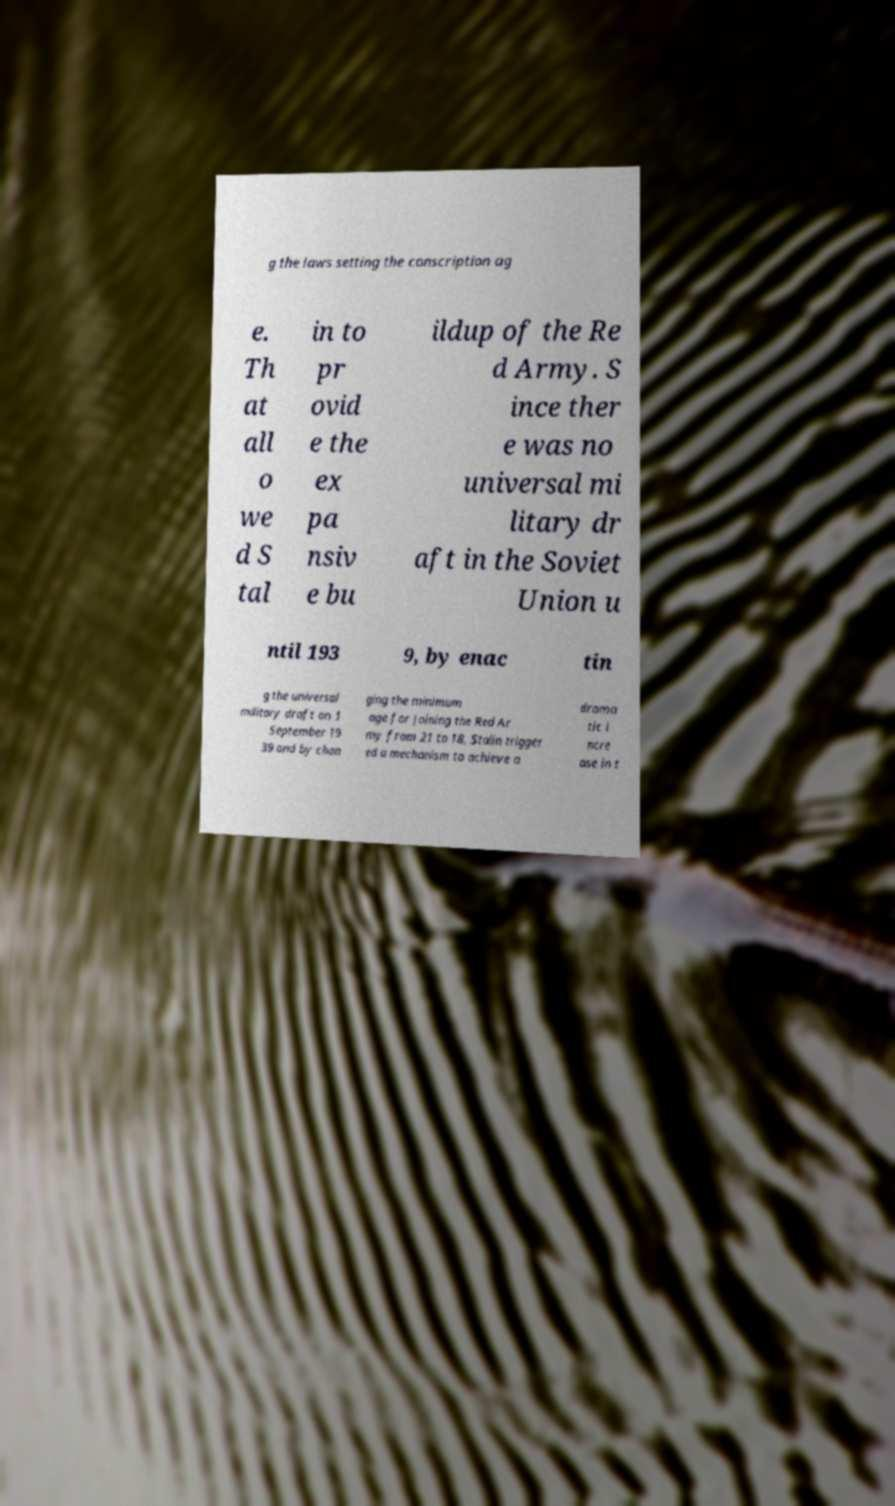Please read and relay the text visible in this image. What does it say? g the laws setting the conscription ag e. Th at all o we d S tal in to pr ovid e the ex pa nsiv e bu ildup of the Re d Army. S ince ther e was no universal mi litary dr aft in the Soviet Union u ntil 193 9, by enac tin g the universal military draft on 1 September 19 39 and by chan ging the minimum age for joining the Red Ar my from 21 to 18, Stalin trigger ed a mechanism to achieve a drama tic i ncre ase in t 